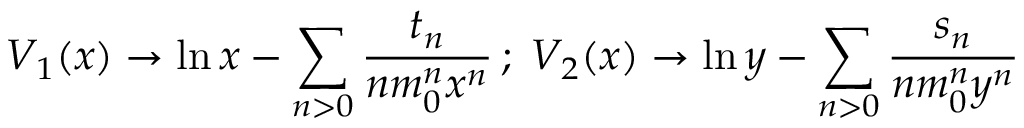<formula> <loc_0><loc_0><loc_500><loc_500>V _ { 1 } ( x ) \rightarrow \ln x - \sum _ { n > 0 } \frac { t _ { n } } { n m _ { 0 } ^ { n } x ^ { n } } \, ; \, V _ { 2 } ( x ) \rightarrow \ln y - \sum _ { n > 0 } \frac { s _ { n } } { n m _ { 0 } ^ { n } y ^ { n } }</formula> 